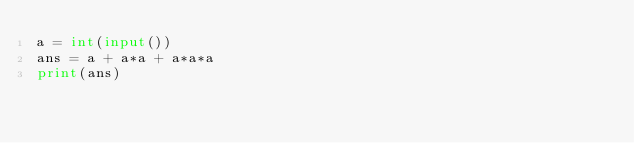Convert code to text. <code><loc_0><loc_0><loc_500><loc_500><_Python_>a = int(input())
ans = a + a*a + a*a*a
print(ans)</code> 